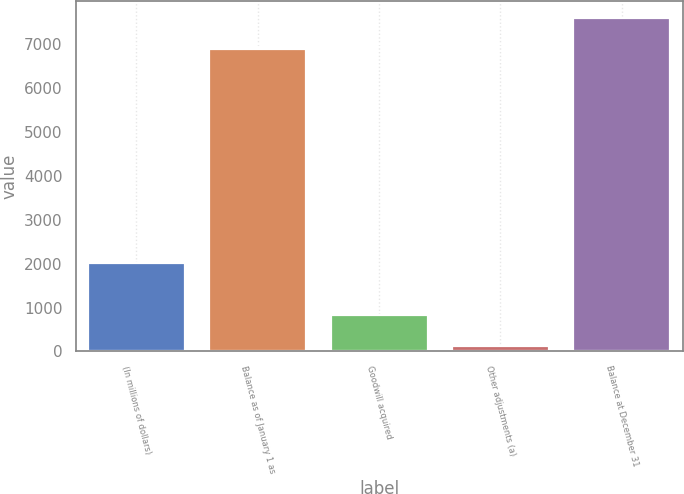<chart> <loc_0><loc_0><loc_500><loc_500><bar_chart><fcel>(In millions of dollars)<fcel>Balance as of January 1 as<fcel>Goodwill acquired<fcel>Other adjustments (a)<fcel>Balance at December 31<nl><fcel>2014<fcel>6893<fcel>835.7<fcel>124<fcel>7604.7<nl></chart> 